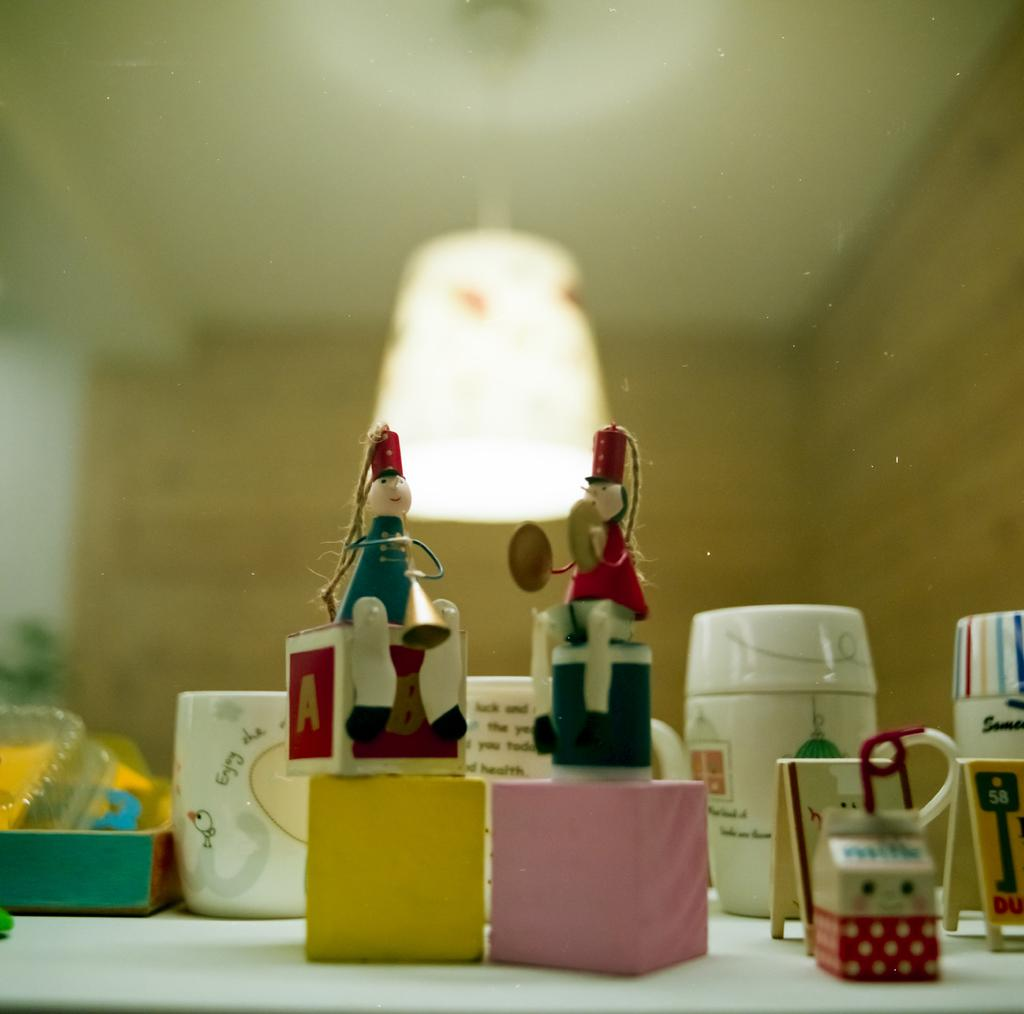What is located at the bottom of the image? There is a table at the bottom of the image. What objects can be seen on the table? Blocks, dolls, mugs, a box, and toys are present on the table. What can be seen in the background of the image? There is a light and a wall in the background of the image. How many girls are walking along the route in the image? There are no girls or routes present in the image; it features a table with various objects on it and a background with a light and a wall. 